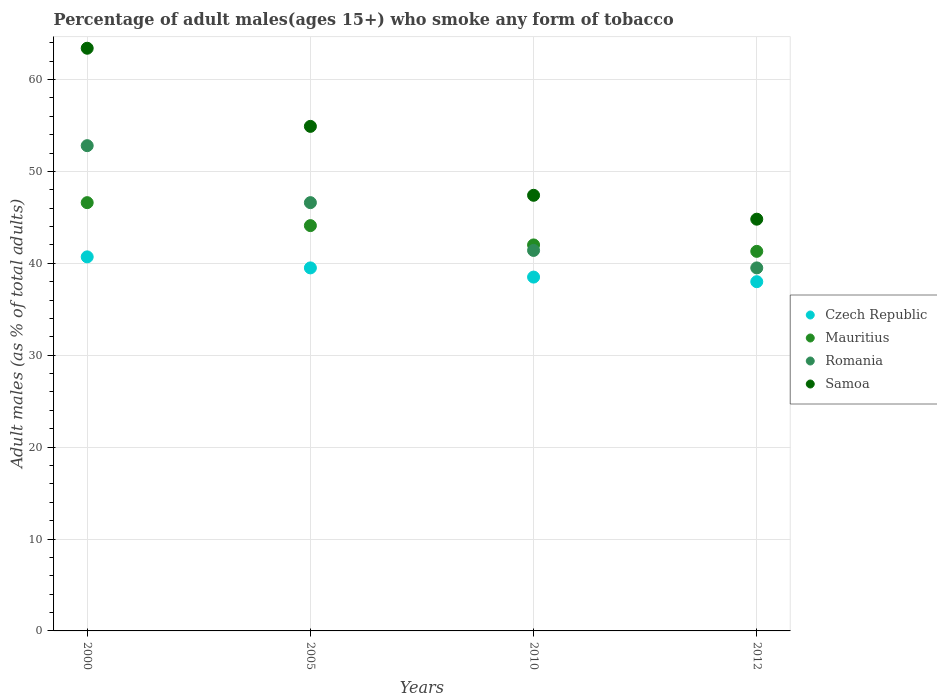What is the percentage of adult males who smoke in Romania in 2000?
Provide a succinct answer. 52.8. Across all years, what is the maximum percentage of adult males who smoke in Czech Republic?
Offer a very short reply. 40.7. Across all years, what is the minimum percentage of adult males who smoke in Mauritius?
Offer a terse response. 41.3. In which year was the percentage of adult males who smoke in Romania minimum?
Your answer should be compact. 2012. What is the total percentage of adult males who smoke in Samoa in the graph?
Offer a terse response. 210.5. What is the difference between the percentage of adult males who smoke in Romania in 2005 and that in 2010?
Ensure brevity in your answer.  5.2. What is the difference between the percentage of adult males who smoke in Czech Republic in 2012 and the percentage of adult males who smoke in Samoa in 2010?
Your response must be concise. -9.4. What is the average percentage of adult males who smoke in Czech Republic per year?
Your answer should be very brief. 39.17. In the year 2000, what is the difference between the percentage of adult males who smoke in Czech Republic and percentage of adult males who smoke in Romania?
Provide a short and direct response. -12.1. What is the ratio of the percentage of adult males who smoke in Czech Republic in 2005 to that in 2012?
Provide a succinct answer. 1.04. Is the difference between the percentage of adult males who smoke in Czech Republic in 2000 and 2010 greater than the difference between the percentage of adult males who smoke in Romania in 2000 and 2010?
Ensure brevity in your answer.  No. What is the difference between the highest and the second highest percentage of adult males who smoke in Romania?
Provide a short and direct response. 6.2. What is the difference between the highest and the lowest percentage of adult males who smoke in Czech Republic?
Offer a very short reply. 2.7. In how many years, is the percentage of adult males who smoke in Samoa greater than the average percentage of adult males who smoke in Samoa taken over all years?
Keep it short and to the point. 2. Is it the case that in every year, the sum of the percentage of adult males who smoke in Czech Republic and percentage of adult males who smoke in Romania  is greater than the sum of percentage of adult males who smoke in Mauritius and percentage of adult males who smoke in Samoa?
Keep it short and to the point. No. Is the percentage of adult males who smoke in Mauritius strictly less than the percentage of adult males who smoke in Czech Republic over the years?
Keep it short and to the point. No. How many dotlines are there?
Make the answer very short. 4. How many years are there in the graph?
Give a very brief answer. 4. How many legend labels are there?
Provide a succinct answer. 4. How are the legend labels stacked?
Keep it short and to the point. Vertical. What is the title of the graph?
Make the answer very short. Percentage of adult males(ages 15+) who smoke any form of tobacco. Does "Puerto Rico" appear as one of the legend labels in the graph?
Provide a succinct answer. No. What is the label or title of the Y-axis?
Your response must be concise. Adult males (as % of total adults). What is the Adult males (as % of total adults) of Czech Republic in 2000?
Provide a succinct answer. 40.7. What is the Adult males (as % of total adults) in Mauritius in 2000?
Your response must be concise. 46.6. What is the Adult males (as % of total adults) in Romania in 2000?
Your response must be concise. 52.8. What is the Adult males (as % of total adults) in Samoa in 2000?
Keep it short and to the point. 63.4. What is the Adult males (as % of total adults) in Czech Republic in 2005?
Your answer should be compact. 39.5. What is the Adult males (as % of total adults) of Mauritius in 2005?
Ensure brevity in your answer.  44.1. What is the Adult males (as % of total adults) of Romania in 2005?
Provide a short and direct response. 46.6. What is the Adult males (as % of total adults) of Samoa in 2005?
Offer a terse response. 54.9. What is the Adult males (as % of total adults) in Czech Republic in 2010?
Provide a short and direct response. 38.5. What is the Adult males (as % of total adults) of Mauritius in 2010?
Keep it short and to the point. 42. What is the Adult males (as % of total adults) of Romania in 2010?
Your answer should be very brief. 41.4. What is the Adult males (as % of total adults) of Samoa in 2010?
Offer a terse response. 47.4. What is the Adult males (as % of total adults) in Czech Republic in 2012?
Offer a very short reply. 38. What is the Adult males (as % of total adults) of Mauritius in 2012?
Ensure brevity in your answer.  41.3. What is the Adult males (as % of total adults) in Romania in 2012?
Ensure brevity in your answer.  39.5. What is the Adult males (as % of total adults) in Samoa in 2012?
Give a very brief answer. 44.8. Across all years, what is the maximum Adult males (as % of total adults) of Czech Republic?
Ensure brevity in your answer.  40.7. Across all years, what is the maximum Adult males (as % of total adults) of Mauritius?
Keep it short and to the point. 46.6. Across all years, what is the maximum Adult males (as % of total adults) of Romania?
Offer a terse response. 52.8. Across all years, what is the maximum Adult males (as % of total adults) in Samoa?
Ensure brevity in your answer.  63.4. Across all years, what is the minimum Adult males (as % of total adults) in Mauritius?
Make the answer very short. 41.3. Across all years, what is the minimum Adult males (as % of total adults) in Romania?
Keep it short and to the point. 39.5. Across all years, what is the minimum Adult males (as % of total adults) in Samoa?
Make the answer very short. 44.8. What is the total Adult males (as % of total adults) of Czech Republic in the graph?
Your answer should be compact. 156.7. What is the total Adult males (as % of total adults) in Mauritius in the graph?
Offer a terse response. 174. What is the total Adult males (as % of total adults) in Romania in the graph?
Offer a very short reply. 180.3. What is the total Adult males (as % of total adults) in Samoa in the graph?
Offer a very short reply. 210.5. What is the difference between the Adult males (as % of total adults) of Czech Republic in 2000 and that in 2005?
Provide a short and direct response. 1.2. What is the difference between the Adult males (as % of total adults) of Mauritius in 2000 and that in 2010?
Ensure brevity in your answer.  4.6. What is the difference between the Adult males (as % of total adults) of Mauritius in 2000 and that in 2012?
Ensure brevity in your answer.  5.3. What is the difference between the Adult males (as % of total adults) of Samoa in 2000 and that in 2012?
Ensure brevity in your answer.  18.6. What is the difference between the Adult males (as % of total adults) of Romania in 2005 and that in 2010?
Your response must be concise. 5.2. What is the difference between the Adult males (as % of total adults) in Samoa in 2005 and that in 2010?
Keep it short and to the point. 7.5. What is the difference between the Adult males (as % of total adults) in Czech Republic in 2005 and that in 2012?
Your answer should be compact. 1.5. What is the difference between the Adult males (as % of total adults) in Romania in 2005 and that in 2012?
Give a very brief answer. 7.1. What is the difference between the Adult males (as % of total adults) in Czech Republic in 2010 and that in 2012?
Provide a short and direct response. 0.5. What is the difference between the Adult males (as % of total adults) of Mauritius in 2010 and that in 2012?
Provide a short and direct response. 0.7. What is the difference between the Adult males (as % of total adults) of Romania in 2010 and that in 2012?
Offer a very short reply. 1.9. What is the difference between the Adult males (as % of total adults) in Samoa in 2010 and that in 2012?
Offer a terse response. 2.6. What is the difference between the Adult males (as % of total adults) of Czech Republic in 2000 and the Adult males (as % of total adults) of Mauritius in 2005?
Your answer should be compact. -3.4. What is the difference between the Adult males (as % of total adults) of Mauritius in 2000 and the Adult males (as % of total adults) of Samoa in 2005?
Your answer should be compact. -8.3. What is the difference between the Adult males (as % of total adults) of Romania in 2000 and the Adult males (as % of total adults) of Samoa in 2005?
Give a very brief answer. -2.1. What is the difference between the Adult males (as % of total adults) in Czech Republic in 2000 and the Adult males (as % of total adults) in Mauritius in 2010?
Offer a very short reply. -1.3. What is the difference between the Adult males (as % of total adults) of Czech Republic in 2000 and the Adult males (as % of total adults) of Romania in 2010?
Your answer should be compact. -0.7. What is the difference between the Adult males (as % of total adults) in Romania in 2000 and the Adult males (as % of total adults) in Samoa in 2010?
Your answer should be very brief. 5.4. What is the difference between the Adult males (as % of total adults) of Czech Republic in 2000 and the Adult males (as % of total adults) of Mauritius in 2012?
Keep it short and to the point. -0.6. What is the difference between the Adult males (as % of total adults) in Czech Republic in 2000 and the Adult males (as % of total adults) in Romania in 2012?
Make the answer very short. 1.2. What is the difference between the Adult males (as % of total adults) in Mauritius in 2000 and the Adult males (as % of total adults) in Samoa in 2012?
Offer a very short reply. 1.8. What is the difference between the Adult males (as % of total adults) in Czech Republic in 2005 and the Adult males (as % of total adults) in Mauritius in 2010?
Your response must be concise. -2.5. What is the difference between the Adult males (as % of total adults) in Czech Republic in 2005 and the Adult males (as % of total adults) in Samoa in 2010?
Provide a succinct answer. -7.9. What is the difference between the Adult males (as % of total adults) in Mauritius in 2005 and the Adult males (as % of total adults) in Romania in 2010?
Provide a succinct answer. 2.7. What is the difference between the Adult males (as % of total adults) of Romania in 2005 and the Adult males (as % of total adults) of Samoa in 2010?
Ensure brevity in your answer.  -0.8. What is the difference between the Adult males (as % of total adults) in Czech Republic in 2005 and the Adult males (as % of total adults) in Mauritius in 2012?
Your answer should be compact. -1.8. What is the difference between the Adult males (as % of total adults) of Czech Republic in 2005 and the Adult males (as % of total adults) of Samoa in 2012?
Offer a terse response. -5.3. What is the difference between the Adult males (as % of total adults) in Mauritius in 2005 and the Adult males (as % of total adults) in Romania in 2012?
Your answer should be compact. 4.6. What is the difference between the Adult males (as % of total adults) in Romania in 2005 and the Adult males (as % of total adults) in Samoa in 2012?
Make the answer very short. 1.8. What is the difference between the Adult males (as % of total adults) of Czech Republic in 2010 and the Adult males (as % of total adults) of Mauritius in 2012?
Offer a very short reply. -2.8. What is the difference between the Adult males (as % of total adults) of Czech Republic in 2010 and the Adult males (as % of total adults) of Romania in 2012?
Keep it short and to the point. -1. What is the difference between the Adult males (as % of total adults) of Czech Republic in 2010 and the Adult males (as % of total adults) of Samoa in 2012?
Provide a succinct answer. -6.3. What is the difference between the Adult males (as % of total adults) in Mauritius in 2010 and the Adult males (as % of total adults) in Romania in 2012?
Your response must be concise. 2.5. What is the difference between the Adult males (as % of total adults) of Mauritius in 2010 and the Adult males (as % of total adults) of Samoa in 2012?
Ensure brevity in your answer.  -2.8. What is the difference between the Adult males (as % of total adults) of Romania in 2010 and the Adult males (as % of total adults) of Samoa in 2012?
Offer a terse response. -3.4. What is the average Adult males (as % of total adults) in Czech Republic per year?
Your answer should be very brief. 39.17. What is the average Adult males (as % of total adults) in Mauritius per year?
Your response must be concise. 43.5. What is the average Adult males (as % of total adults) of Romania per year?
Offer a very short reply. 45.08. What is the average Adult males (as % of total adults) of Samoa per year?
Make the answer very short. 52.62. In the year 2000, what is the difference between the Adult males (as % of total adults) in Czech Republic and Adult males (as % of total adults) in Romania?
Your answer should be very brief. -12.1. In the year 2000, what is the difference between the Adult males (as % of total adults) in Czech Republic and Adult males (as % of total adults) in Samoa?
Your answer should be very brief. -22.7. In the year 2000, what is the difference between the Adult males (as % of total adults) of Mauritius and Adult males (as % of total adults) of Samoa?
Your response must be concise. -16.8. In the year 2000, what is the difference between the Adult males (as % of total adults) of Romania and Adult males (as % of total adults) of Samoa?
Provide a succinct answer. -10.6. In the year 2005, what is the difference between the Adult males (as % of total adults) of Czech Republic and Adult males (as % of total adults) of Mauritius?
Your answer should be very brief. -4.6. In the year 2005, what is the difference between the Adult males (as % of total adults) in Czech Republic and Adult males (as % of total adults) in Samoa?
Give a very brief answer. -15.4. In the year 2005, what is the difference between the Adult males (as % of total adults) of Romania and Adult males (as % of total adults) of Samoa?
Offer a terse response. -8.3. In the year 2010, what is the difference between the Adult males (as % of total adults) in Czech Republic and Adult males (as % of total adults) in Samoa?
Your answer should be compact. -8.9. In the year 2010, what is the difference between the Adult males (as % of total adults) of Mauritius and Adult males (as % of total adults) of Romania?
Keep it short and to the point. 0.6. In the year 2010, what is the difference between the Adult males (as % of total adults) of Romania and Adult males (as % of total adults) of Samoa?
Offer a very short reply. -6. In the year 2012, what is the difference between the Adult males (as % of total adults) of Czech Republic and Adult males (as % of total adults) of Samoa?
Your answer should be very brief. -6.8. In the year 2012, what is the difference between the Adult males (as % of total adults) of Mauritius and Adult males (as % of total adults) of Romania?
Keep it short and to the point. 1.8. In the year 2012, what is the difference between the Adult males (as % of total adults) in Romania and Adult males (as % of total adults) in Samoa?
Offer a very short reply. -5.3. What is the ratio of the Adult males (as % of total adults) in Czech Republic in 2000 to that in 2005?
Give a very brief answer. 1.03. What is the ratio of the Adult males (as % of total adults) of Mauritius in 2000 to that in 2005?
Provide a short and direct response. 1.06. What is the ratio of the Adult males (as % of total adults) of Romania in 2000 to that in 2005?
Make the answer very short. 1.13. What is the ratio of the Adult males (as % of total adults) in Samoa in 2000 to that in 2005?
Provide a short and direct response. 1.15. What is the ratio of the Adult males (as % of total adults) of Czech Republic in 2000 to that in 2010?
Give a very brief answer. 1.06. What is the ratio of the Adult males (as % of total adults) in Mauritius in 2000 to that in 2010?
Make the answer very short. 1.11. What is the ratio of the Adult males (as % of total adults) in Romania in 2000 to that in 2010?
Make the answer very short. 1.28. What is the ratio of the Adult males (as % of total adults) of Samoa in 2000 to that in 2010?
Keep it short and to the point. 1.34. What is the ratio of the Adult males (as % of total adults) in Czech Republic in 2000 to that in 2012?
Provide a succinct answer. 1.07. What is the ratio of the Adult males (as % of total adults) in Mauritius in 2000 to that in 2012?
Make the answer very short. 1.13. What is the ratio of the Adult males (as % of total adults) of Romania in 2000 to that in 2012?
Make the answer very short. 1.34. What is the ratio of the Adult males (as % of total adults) of Samoa in 2000 to that in 2012?
Your answer should be compact. 1.42. What is the ratio of the Adult males (as % of total adults) in Czech Republic in 2005 to that in 2010?
Offer a terse response. 1.03. What is the ratio of the Adult males (as % of total adults) in Mauritius in 2005 to that in 2010?
Give a very brief answer. 1.05. What is the ratio of the Adult males (as % of total adults) of Romania in 2005 to that in 2010?
Keep it short and to the point. 1.13. What is the ratio of the Adult males (as % of total adults) of Samoa in 2005 to that in 2010?
Keep it short and to the point. 1.16. What is the ratio of the Adult males (as % of total adults) of Czech Republic in 2005 to that in 2012?
Your response must be concise. 1.04. What is the ratio of the Adult males (as % of total adults) in Mauritius in 2005 to that in 2012?
Ensure brevity in your answer.  1.07. What is the ratio of the Adult males (as % of total adults) of Romania in 2005 to that in 2012?
Provide a short and direct response. 1.18. What is the ratio of the Adult males (as % of total adults) of Samoa in 2005 to that in 2012?
Your answer should be compact. 1.23. What is the ratio of the Adult males (as % of total adults) in Czech Republic in 2010 to that in 2012?
Offer a very short reply. 1.01. What is the ratio of the Adult males (as % of total adults) in Mauritius in 2010 to that in 2012?
Your response must be concise. 1.02. What is the ratio of the Adult males (as % of total adults) in Romania in 2010 to that in 2012?
Make the answer very short. 1.05. What is the ratio of the Adult males (as % of total adults) of Samoa in 2010 to that in 2012?
Your answer should be compact. 1.06. What is the difference between the highest and the lowest Adult males (as % of total adults) of Czech Republic?
Give a very brief answer. 2.7. What is the difference between the highest and the lowest Adult males (as % of total adults) in Romania?
Your response must be concise. 13.3. 